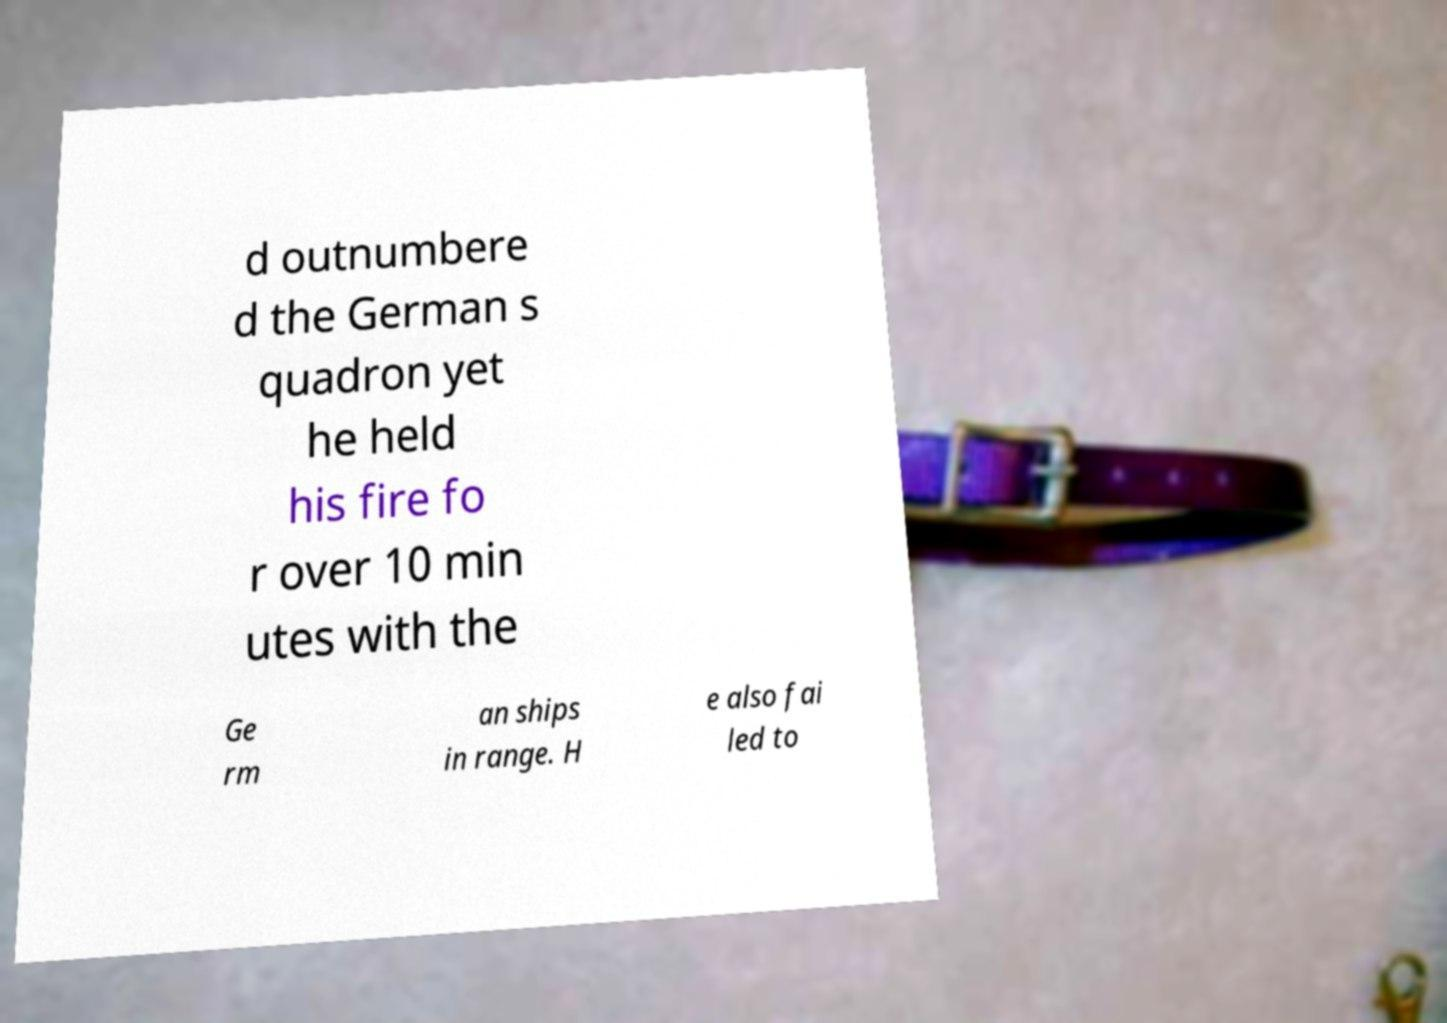Could you assist in decoding the text presented in this image and type it out clearly? d outnumbere d the German s quadron yet he held his fire fo r over 10 min utes with the Ge rm an ships in range. H e also fai led to 